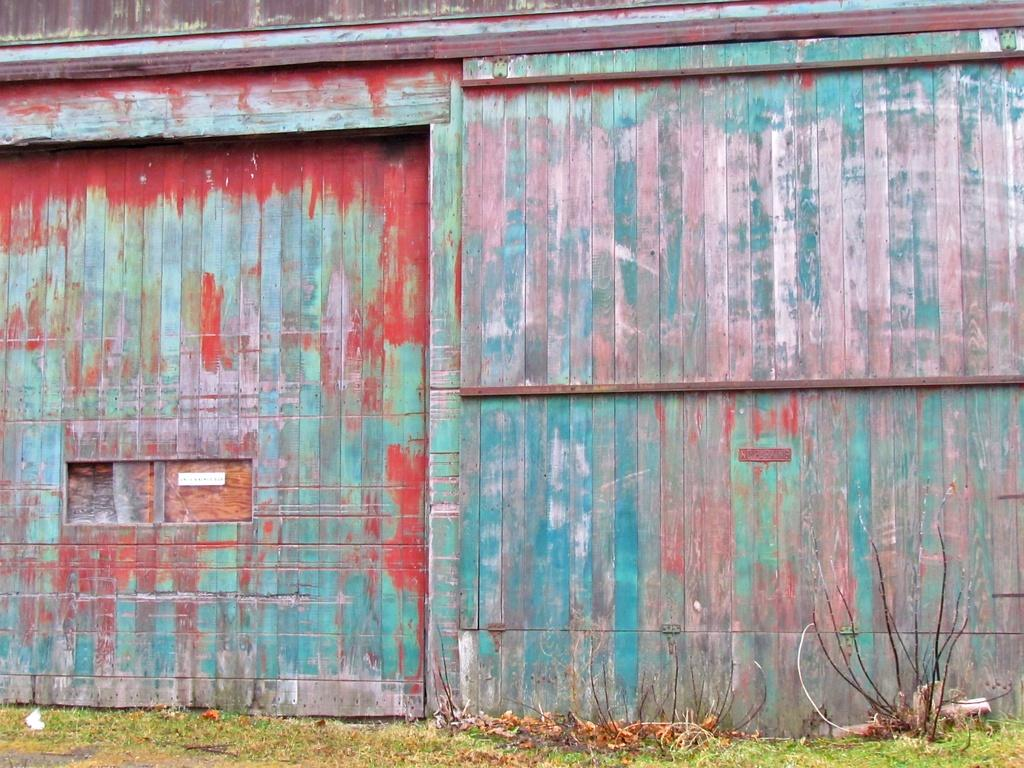What type of wall is visible in the image? There is a wooden wall in the image. What is located in front of the wooden wall? There are plants and grass in front of the wooden wall. How does the feeling of the wooden wall compare to the texture of the snakes in the image? There are no snakes present in the image, so it is not possible to compare the feeling of the wooden wall to the texture of snakes. 